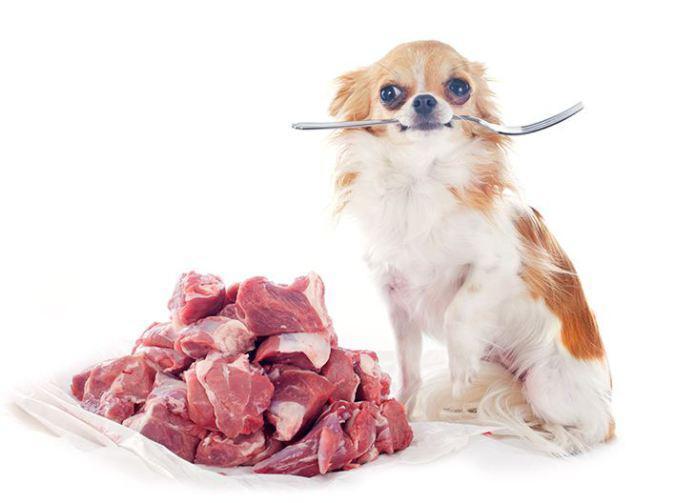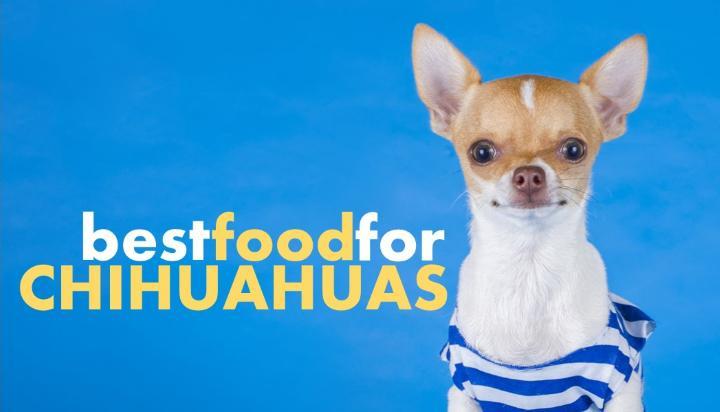The first image is the image on the left, the second image is the image on the right. Assess this claim about the two images: "The left image contains one dog that has a fork in its mouth.". Correct or not? Answer yes or no. Yes. The first image is the image on the left, the second image is the image on the right. Analyze the images presented: Is the assertion "The left image shows a chihuahua with a fork handle in its mouth sitting behind food." valid? Answer yes or no. Yes. 